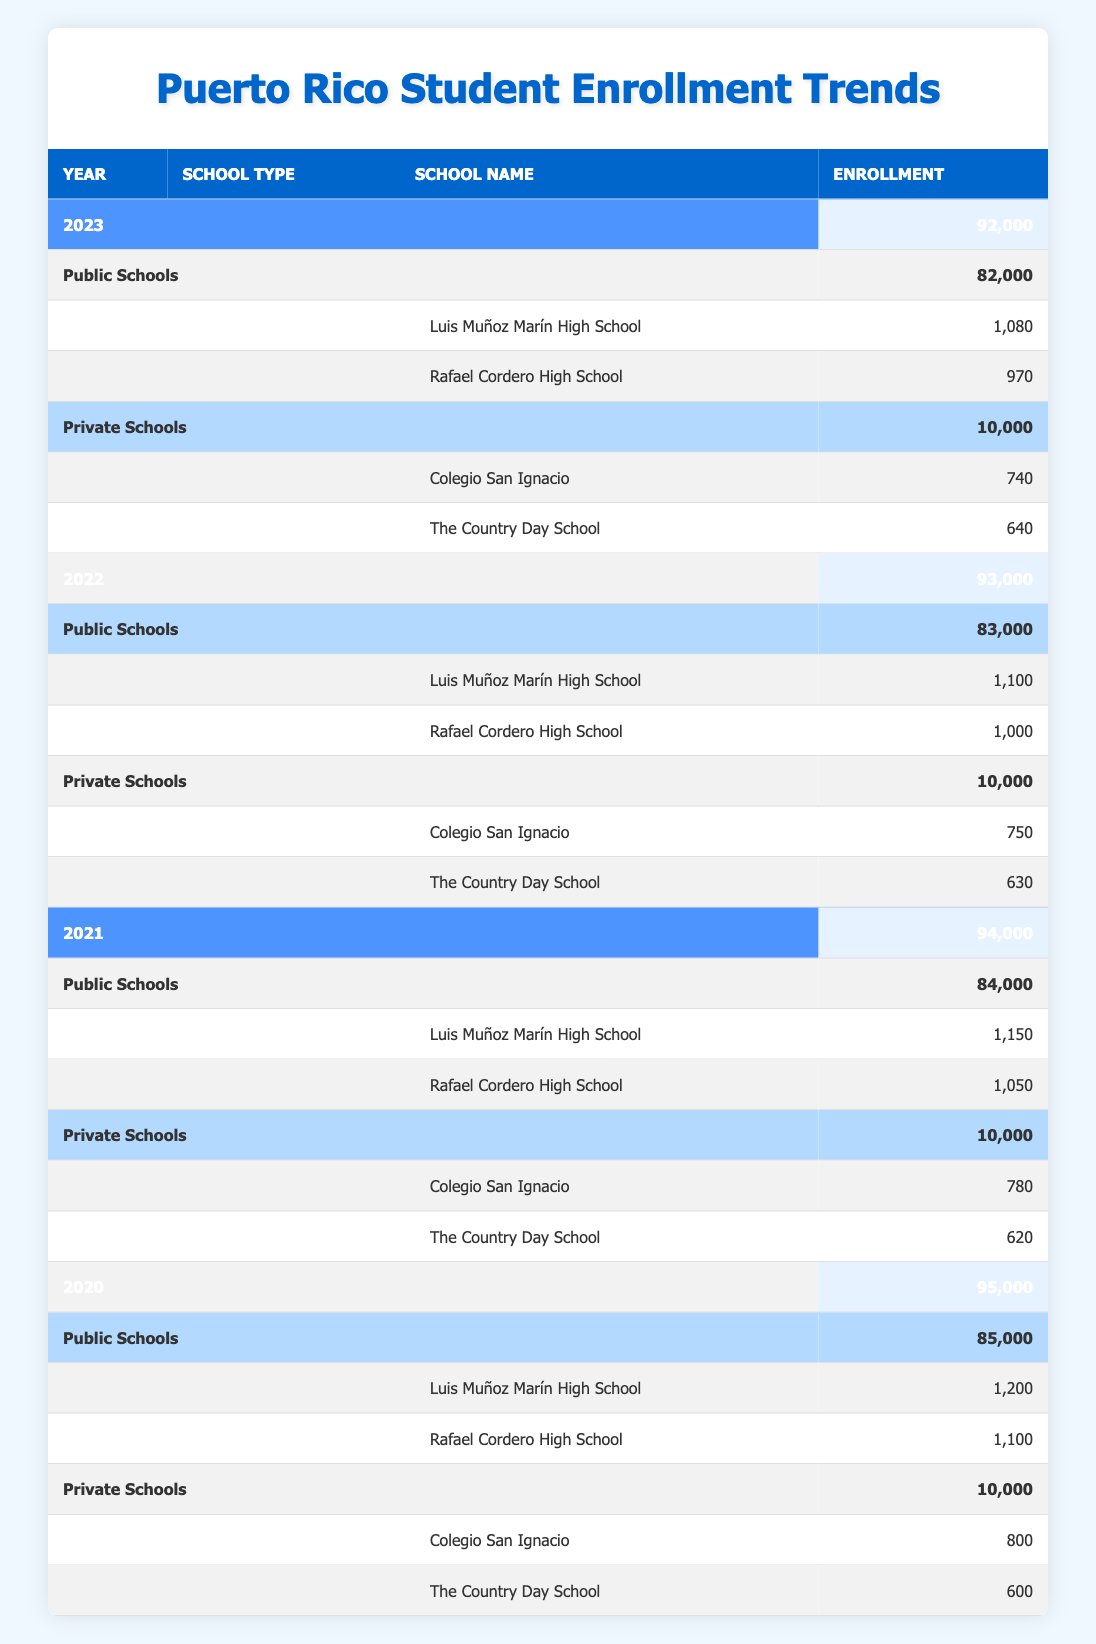What was the total enrollment in Puerto Rican high schools in 2020? According to the table, the total enrollment in 2020 is listed as 95,000.
Answer: 95,000 Which high school had the highest enrollment in 2021? From the table, in 2021, the school with the highest enrollment is Luis Muñoz Marín High School with 1,150 students.
Answer: Luis Muñoz Marín High School What is the difference in total enrollment between 2020 and 2023? To find the difference, subtract the total enrollment of 2023 (92,000) from 2020 (95,000). This yields 95,000 - 92,000 = 3,000.
Answer: 3,000 Did the enrollment in private schools increase from 2020 to 2021? Looking at the enrollments for private schools, in 2020 it is 10,000 and in 2021 it remains the same at 10,000, thus it did not increase.
Answer: No What is the average enrollment for the two public high schools in 2022? The enrollments for the public schools in 2022 are Luis Muñoz Marín High School with 1,100 and Rafael Cordero High School with 1,000. The average is calculated by (1,100 + 1,000) / 2 = 1,050.
Answer: 1,050 Which year saw the lowest overall enrollment? Observing the table, the data shows that 2023 has the lowest total enrollment of 92,000 when compared to all other years listed.
Answer: 2023 How many students were enrolled in private schools in 2022 compared to 2023? The enrollment in private schools for 2022 is 10,000 and for 2023 is also 10,000, indicating no change between these two years.
Answer: No change What was the total public school enrollment in 2021? The table indicates that the total public school enrollment for 2021 is 84,000, providing a specific value from the data.
Answer: 84,000 Which private school had the lowest enrollment in 2020? From the entries for private schools in 2020, The Country Day School had the lowest enrollment with 600 students while Colegio San Ignacio had 800.
Answer: The Country Day School 